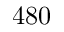Convert formula to latex. <formula><loc_0><loc_0><loc_500><loc_500>4 8 0</formula> 